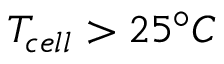Convert formula to latex. <formula><loc_0><loc_0><loc_500><loc_500>T _ { c e l l } > 2 5 ^ { \circ } C</formula> 